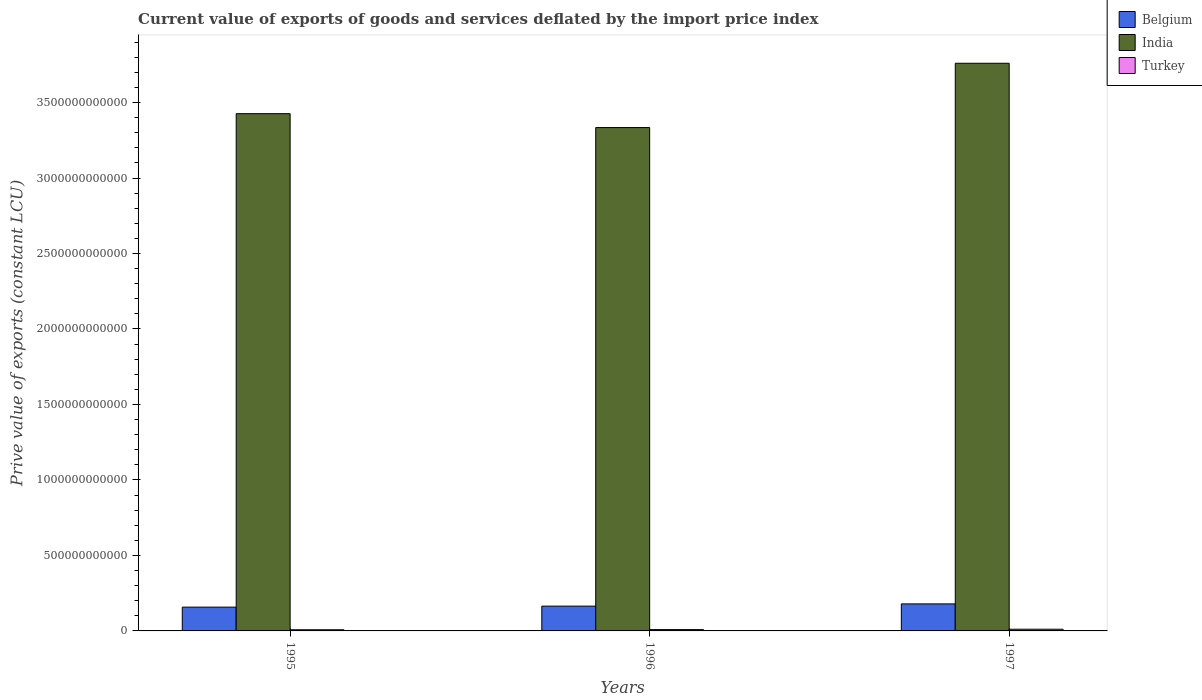Are the number of bars on each tick of the X-axis equal?
Provide a succinct answer. Yes. How many bars are there on the 3rd tick from the left?
Offer a very short reply. 3. How many bars are there on the 2nd tick from the right?
Your answer should be very brief. 3. In how many cases, is the number of bars for a given year not equal to the number of legend labels?
Your answer should be very brief. 0. What is the prive value of exports in Belgium in 1996?
Make the answer very short. 1.64e+11. Across all years, what is the maximum prive value of exports in Turkey?
Your answer should be very brief. 1.12e+1. Across all years, what is the minimum prive value of exports in Turkey?
Offer a terse response. 7.66e+09. What is the total prive value of exports in Turkey in the graph?
Provide a succinct answer. 2.76e+1. What is the difference between the prive value of exports in Belgium in 1995 and that in 1997?
Offer a very short reply. -2.14e+1. What is the difference between the prive value of exports in India in 1997 and the prive value of exports in Belgium in 1995?
Your response must be concise. 3.60e+12. What is the average prive value of exports in India per year?
Your answer should be very brief. 3.51e+12. In the year 1995, what is the difference between the prive value of exports in Belgium and prive value of exports in India?
Offer a very short reply. -3.27e+12. What is the ratio of the prive value of exports in India in 1995 to that in 1996?
Provide a short and direct response. 1.03. What is the difference between the highest and the second highest prive value of exports in Turkey?
Provide a short and direct response. 2.45e+09. What is the difference between the highest and the lowest prive value of exports in India?
Offer a terse response. 4.26e+11. What does the 1st bar from the left in 1996 represents?
Your answer should be very brief. Belgium. What does the 2nd bar from the right in 1995 represents?
Your answer should be very brief. India. Is it the case that in every year, the sum of the prive value of exports in Belgium and prive value of exports in India is greater than the prive value of exports in Turkey?
Your answer should be compact. Yes. How many years are there in the graph?
Provide a short and direct response. 3. What is the difference between two consecutive major ticks on the Y-axis?
Provide a short and direct response. 5.00e+11. Are the values on the major ticks of Y-axis written in scientific E-notation?
Offer a very short reply. No. Where does the legend appear in the graph?
Give a very brief answer. Top right. How many legend labels are there?
Offer a very short reply. 3. What is the title of the graph?
Your answer should be very brief. Current value of exports of goods and services deflated by the import price index. Does "Canada" appear as one of the legend labels in the graph?
Provide a short and direct response. No. What is the label or title of the X-axis?
Make the answer very short. Years. What is the label or title of the Y-axis?
Your answer should be compact. Prive value of exports (constant LCU). What is the Prive value of exports (constant LCU) of Belgium in 1995?
Your answer should be very brief. 1.58e+11. What is the Prive value of exports (constant LCU) in India in 1995?
Your answer should be very brief. 3.43e+12. What is the Prive value of exports (constant LCU) of Turkey in 1995?
Provide a short and direct response. 7.66e+09. What is the Prive value of exports (constant LCU) in Belgium in 1996?
Offer a terse response. 1.64e+11. What is the Prive value of exports (constant LCU) in India in 1996?
Your response must be concise. 3.33e+12. What is the Prive value of exports (constant LCU) of Turkey in 1996?
Ensure brevity in your answer.  8.75e+09. What is the Prive value of exports (constant LCU) of Belgium in 1997?
Offer a very short reply. 1.79e+11. What is the Prive value of exports (constant LCU) in India in 1997?
Keep it short and to the point. 3.76e+12. What is the Prive value of exports (constant LCU) in Turkey in 1997?
Ensure brevity in your answer.  1.12e+1. Across all years, what is the maximum Prive value of exports (constant LCU) in Belgium?
Give a very brief answer. 1.79e+11. Across all years, what is the maximum Prive value of exports (constant LCU) in India?
Provide a short and direct response. 3.76e+12. Across all years, what is the maximum Prive value of exports (constant LCU) in Turkey?
Offer a terse response. 1.12e+1. Across all years, what is the minimum Prive value of exports (constant LCU) in Belgium?
Offer a very short reply. 1.58e+11. Across all years, what is the minimum Prive value of exports (constant LCU) of India?
Provide a succinct answer. 3.33e+12. Across all years, what is the minimum Prive value of exports (constant LCU) of Turkey?
Your response must be concise. 7.66e+09. What is the total Prive value of exports (constant LCU) in Belgium in the graph?
Your response must be concise. 5.01e+11. What is the total Prive value of exports (constant LCU) of India in the graph?
Give a very brief answer. 1.05e+13. What is the total Prive value of exports (constant LCU) of Turkey in the graph?
Your response must be concise. 2.76e+1. What is the difference between the Prive value of exports (constant LCU) of Belgium in 1995 and that in 1996?
Offer a very short reply. -6.63e+09. What is the difference between the Prive value of exports (constant LCU) of India in 1995 and that in 1996?
Your response must be concise. 9.22e+1. What is the difference between the Prive value of exports (constant LCU) of Turkey in 1995 and that in 1996?
Give a very brief answer. -1.09e+09. What is the difference between the Prive value of exports (constant LCU) in Belgium in 1995 and that in 1997?
Give a very brief answer. -2.14e+1. What is the difference between the Prive value of exports (constant LCU) of India in 1995 and that in 1997?
Your answer should be compact. -3.34e+11. What is the difference between the Prive value of exports (constant LCU) of Turkey in 1995 and that in 1997?
Keep it short and to the point. -3.54e+09. What is the difference between the Prive value of exports (constant LCU) of Belgium in 1996 and that in 1997?
Offer a terse response. -1.48e+1. What is the difference between the Prive value of exports (constant LCU) of India in 1996 and that in 1997?
Your answer should be compact. -4.26e+11. What is the difference between the Prive value of exports (constant LCU) in Turkey in 1996 and that in 1997?
Keep it short and to the point. -2.45e+09. What is the difference between the Prive value of exports (constant LCU) in Belgium in 1995 and the Prive value of exports (constant LCU) in India in 1996?
Make the answer very short. -3.18e+12. What is the difference between the Prive value of exports (constant LCU) in Belgium in 1995 and the Prive value of exports (constant LCU) in Turkey in 1996?
Provide a short and direct response. 1.49e+11. What is the difference between the Prive value of exports (constant LCU) of India in 1995 and the Prive value of exports (constant LCU) of Turkey in 1996?
Your answer should be compact. 3.42e+12. What is the difference between the Prive value of exports (constant LCU) in Belgium in 1995 and the Prive value of exports (constant LCU) in India in 1997?
Your answer should be compact. -3.60e+12. What is the difference between the Prive value of exports (constant LCU) in Belgium in 1995 and the Prive value of exports (constant LCU) in Turkey in 1997?
Offer a very short reply. 1.46e+11. What is the difference between the Prive value of exports (constant LCU) in India in 1995 and the Prive value of exports (constant LCU) in Turkey in 1997?
Your answer should be compact. 3.42e+12. What is the difference between the Prive value of exports (constant LCU) in Belgium in 1996 and the Prive value of exports (constant LCU) in India in 1997?
Your answer should be compact. -3.60e+12. What is the difference between the Prive value of exports (constant LCU) of Belgium in 1996 and the Prive value of exports (constant LCU) of Turkey in 1997?
Your answer should be compact. 1.53e+11. What is the difference between the Prive value of exports (constant LCU) of India in 1996 and the Prive value of exports (constant LCU) of Turkey in 1997?
Your answer should be compact. 3.32e+12. What is the average Prive value of exports (constant LCU) of Belgium per year?
Your answer should be very brief. 1.67e+11. What is the average Prive value of exports (constant LCU) of India per year?
Offer a very short reply. 3.51e+12. What is the average Prive value of exports (constant LCU) of Turkey per year?
Give a very brief answer. 9.21e+09. In the year 1995, what is the difference between the Prive value of exports (constant LCU) of Belgium and Prive value of exports (constant LCU) of India?
Your answer should be compact. -3.27e+12. In the year 1995, what is the difference between the Prive value of exports (constant LCU) of Belgium and Prive value of exports (constant LCU) of Turkey?
Offer a terse response. 1.50e+11. In the year 1995, what is the difference between the Prive value of exports (constant LCU) of India and Prive value of exports (constant LCU) of Turkey?
Your answer should be compact. 3.42e+12. In the year 1996, what is the difference between the Prive value of exports (constant LCU) in Belgium and Prive value of exports (constant LCU) in India?
Make the answer very short. -3.17e+12. In the year 1996, what is the difference between the Prive value of exports (constant LCU) in Belgium and Prive value of exports (constant LCU) in Turkey?
Ensure brevity in your answer.  1.55e+11. In the year 1996, what is the difference between the Prive value of exports (constant LCU) of India and Prive value of exports (constant LCU) of Turkey?
Give a very brief answer. 3.33e+12. In the year 1997, what is the difference between the Prive value of exports (constant LCU) in Belgium and Prive value of exports (constant LCU) in India?
Offer a terse response. -3.58e+12. In the year 1997, what is the difference between the Prive value of exports (constant LCU) of Belgium and Prive value of exports (constant LCU) of Turkey?
Your response must be concise. 1.68e+11. In the year 1997, what is the difference between the Prive value of exports (constant LCU) of India and Prive value of exports (constant LCU) of Turkey?
Provide a short and direct response. 3.75e+12. What is the ratio of the Prive value of exports (constant LCU) of Belgium in 1995 to that in 1996?
Your response must be concise. 0.96. What is the ratio of the Prive value of exports (constant LCU) in India in 1995 to that in 1996?
Your answer should be compact. 1.03. What is the ratio of the Prive value of exports (constant LCU) in Turkey in 1995 to that in 1996?
Provide a succinct answer. 0.88. What is the ratio of the Prive value of exports (constant LCU) of Belgium in 1995 to that in 1997?
Offer a terse response. 0.88. What is the ratio of the Prive value of exports (constant LCU) of India in 1995 to that in 1997?
Offer a very short reply. 0.91. What is the ratio of the Prive value of exports (constant LCU) of Turkey in 1995 to that in 1997?
Make the answer very short. 0.68. What is the ratio of the Prive value of exports (constant LCU) of Belgium in 1996 to that in 1997?
Provide a short and direct response. 0.92. What is the ratio of the Prive value of exports (constant LCU) in India in 1996 to that in 1997?
Offer a terse response. 0.89. What is the ratio of the Prive value of exports (constant LCU) of Turkey in 1996 to that in 1997?
Ensure brevity in your answer.  0.78. What is the difference between the highest and the second highest Prive value of exports (constant LCU) of Belgium?
Offer a very short reply. 1.48e+1. What is the difference between the highest and the second highest Prive value of exports (constant LCU) of India?
Offer a very short reply. 3.34e+11. What is the difference between the highest and the second highest Prive value of exports (constant LCU) of Turkey?
Your answer should be compact. 2.45e+09. What is the difference between the highest and the lowest Prive value of exports (constant LCU) in Belgium?
Make the answer very short. 2.14e+1. What is the difference between the highest and the lowest Prive value of exports (constant LCU) of India?
Your answer should be compact. 4.26e+11. What is the difference between the highest and the lowest Prive value of exports (constant LCU) of Turkey?
Your answer should be very brief. 3.54e+09. 